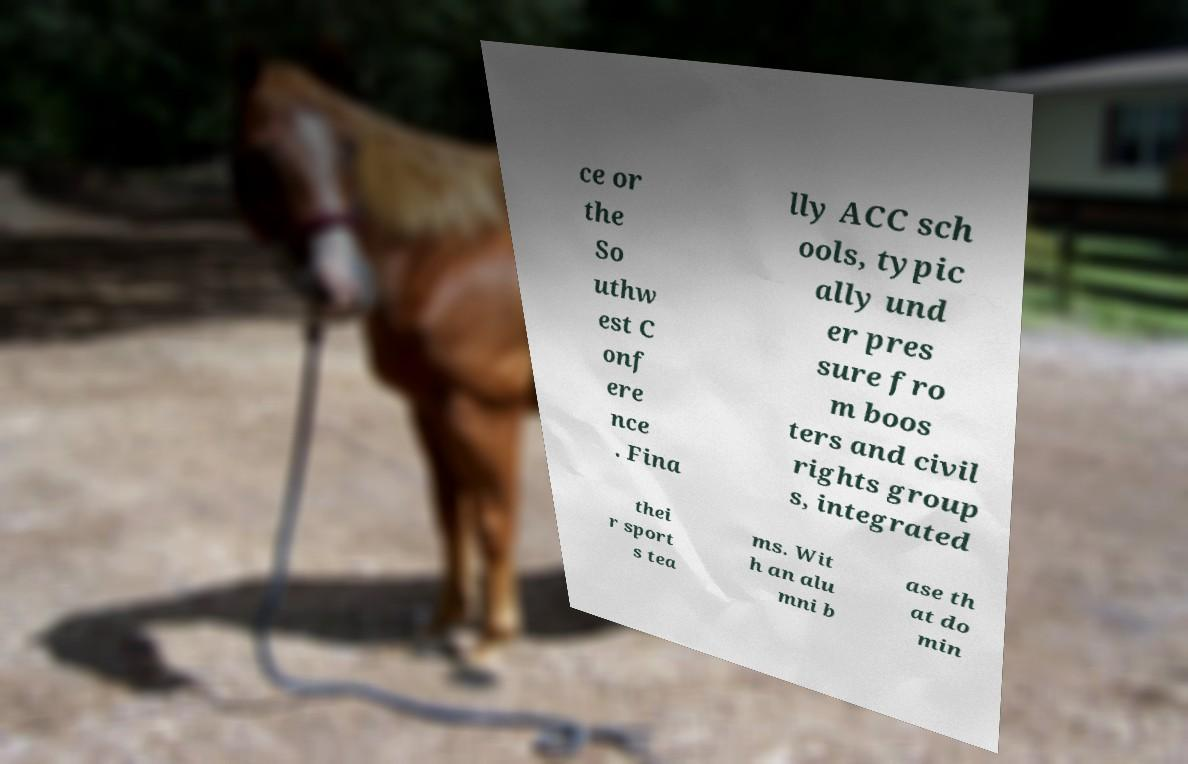Please identify and transcribe the text found in this image. ce or the So uthw est C onf ere nce . Fina lly ACC sch ools, typic ally und er pres sure fro m boos ters and civil rights group s, integrated thei r sport s tea ms. Wit h an alu mni b ase th at do min 